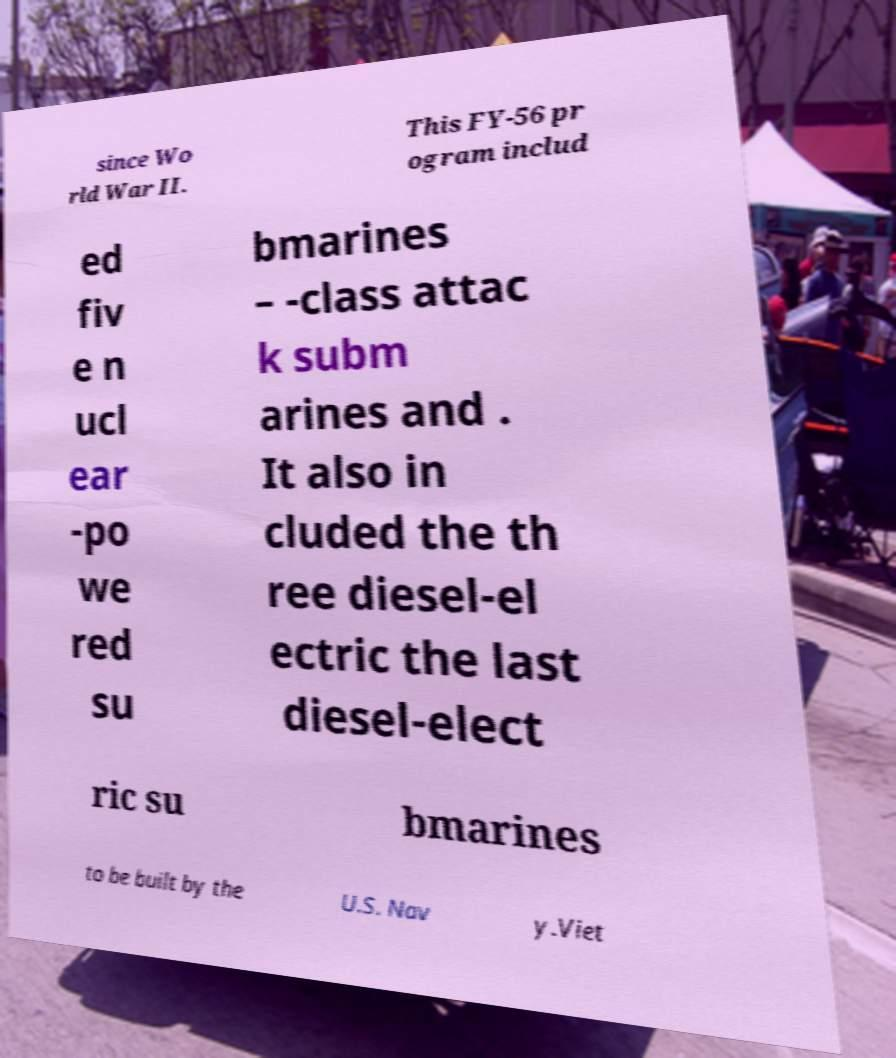Can you accurately transcribe the text from the provided image for me? since Wo rld War II. This FY-56 pr ogram includ ed fiv e n ucl ear -po we red su bmarines – -class attac k subm arines and . It also in cluded the th ree diesel-el ectric the last diesel-elect ric su bmarines to be built by the U.S. Nav y.Viet 